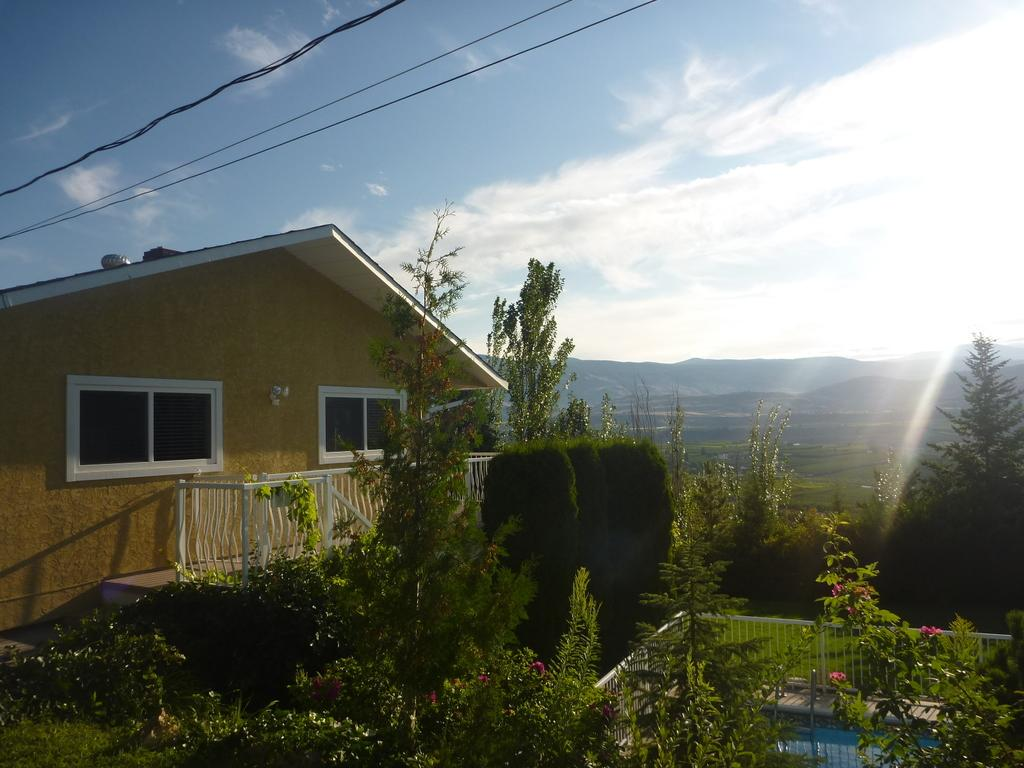What type of vegetation can be seen in the image? There are trees in the image. What natural element is visible in the image? There is water visible in the image. What type of structure is present in the image? There is a house in the image. What materials are present in the image? Metal rods and cables are visible in the image. What is present in the sky in the image? Clouds are present in the image. Can you see any sand in the image? There is no sand present in the image. Is there a kite flying in the sky in the image? There is no kite visible in the image. 